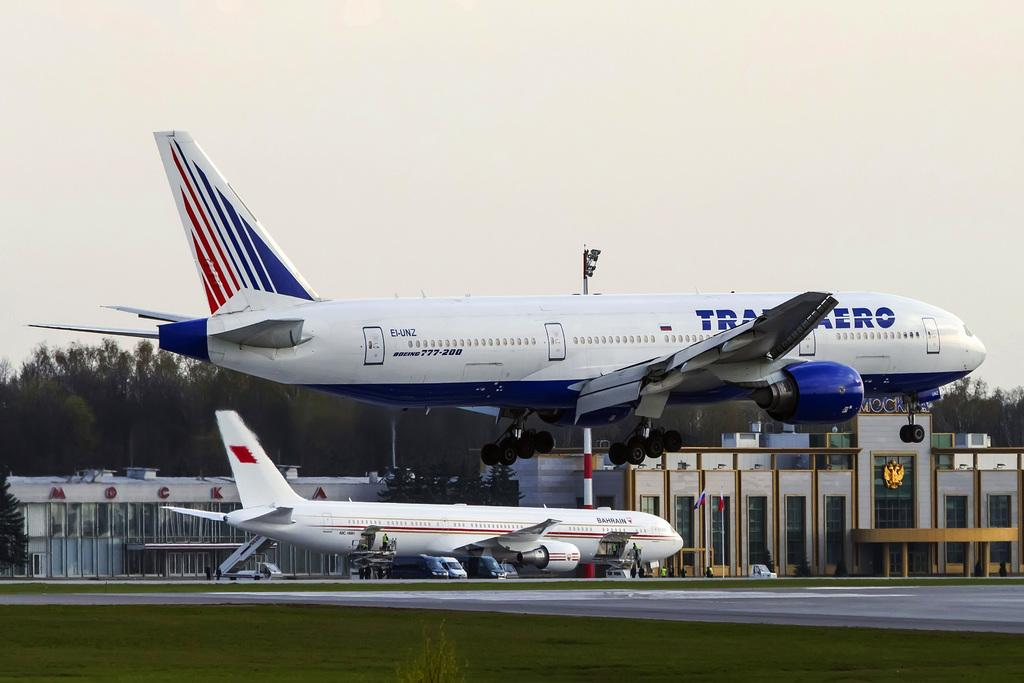Provide a one-sentence caption for the provided image. Two airplanes on the runway where EI-UN2 is taking off into the air and a Bahrain plane below. 